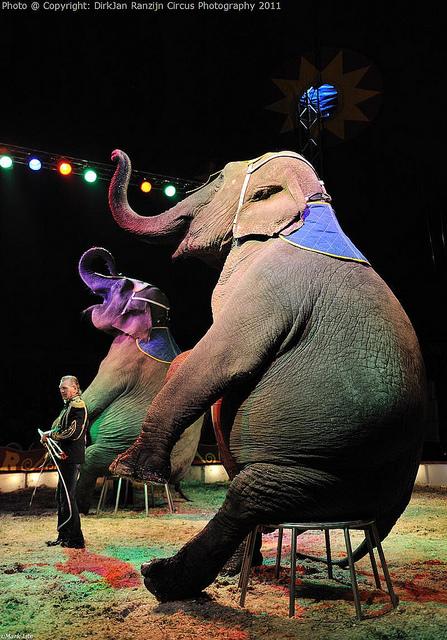Is this at the circus?
Give a very brief answer. Yes. How many elephants are in the scene?
Be succinct. 2. What color are the elephants?
Keep it brief. Gray. Is there an opera singer in this photo?
Keep it brief. No. Is this a circus?
Be succinct. Yes. Are the elephants sitting down?
Short answer required. Yes. 